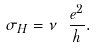<formula> <loc_0><loc_0><loc_500><loc_500>\sigma _ { H } = \nu \ \frac { e ^ { 2 } } { h } .</formula> 